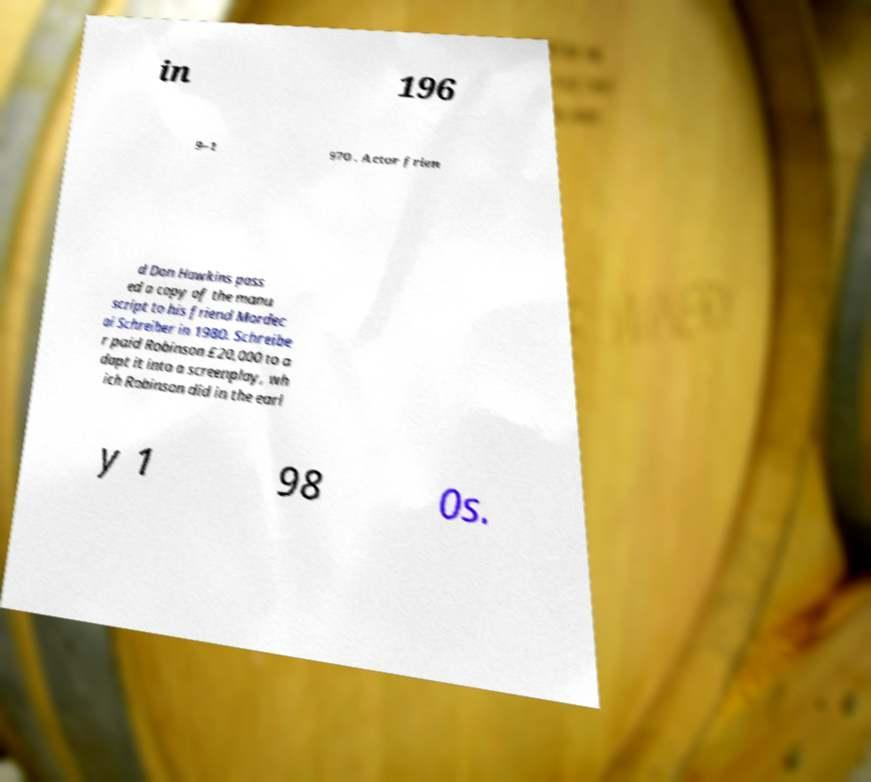There's text embedded in this image that I need extracted. Can you transcribe it verbatim? in 196 9–1 970 . Actor frien d Don Hawkins pass ed a copy of the manu script to his friend Mordec ai Schreiber in 1980. Schreibe r paid Robinson £20,000 to a dapt it into a screenplay, wh ich Robinson did in the earl y 1 98 0s. 